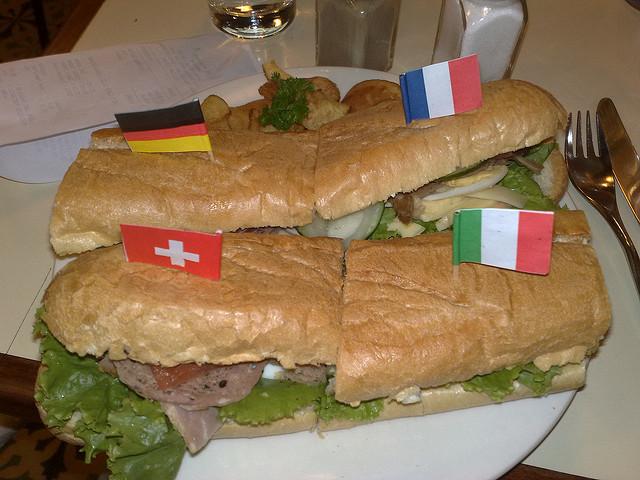Has the sandwich been partially eaten?
Give a very brief answer. No. What is on top of the food?
Short answer required. Flags. How many countries are reflected in this photo?
Be succinct. 4. 